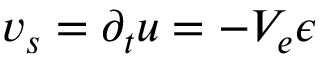Convert formula to latex. <formula><loc_0><loc_0><loc_500><loc_500>v _ { s } = \partial _ { t } u = - V _ { e } \epsilon</formula> 